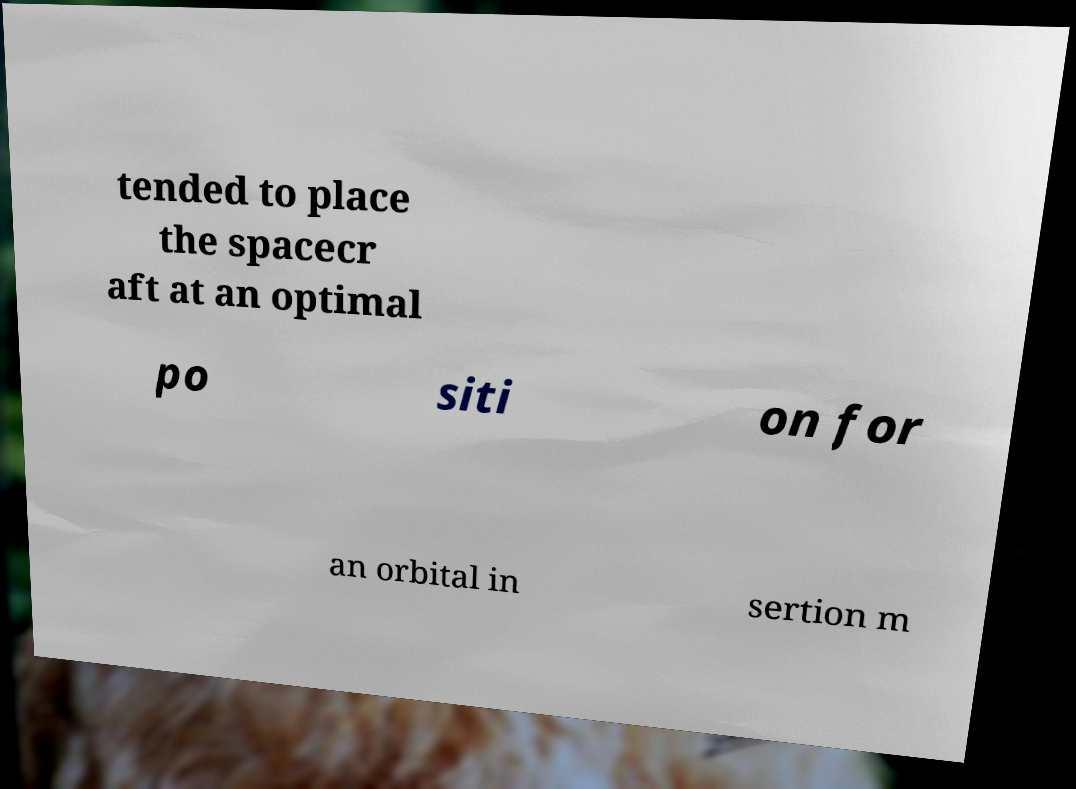Could you extract and type out the text from this image? tended to place the spacecr aft at an optimal po siti on for an orbital in sertion m 